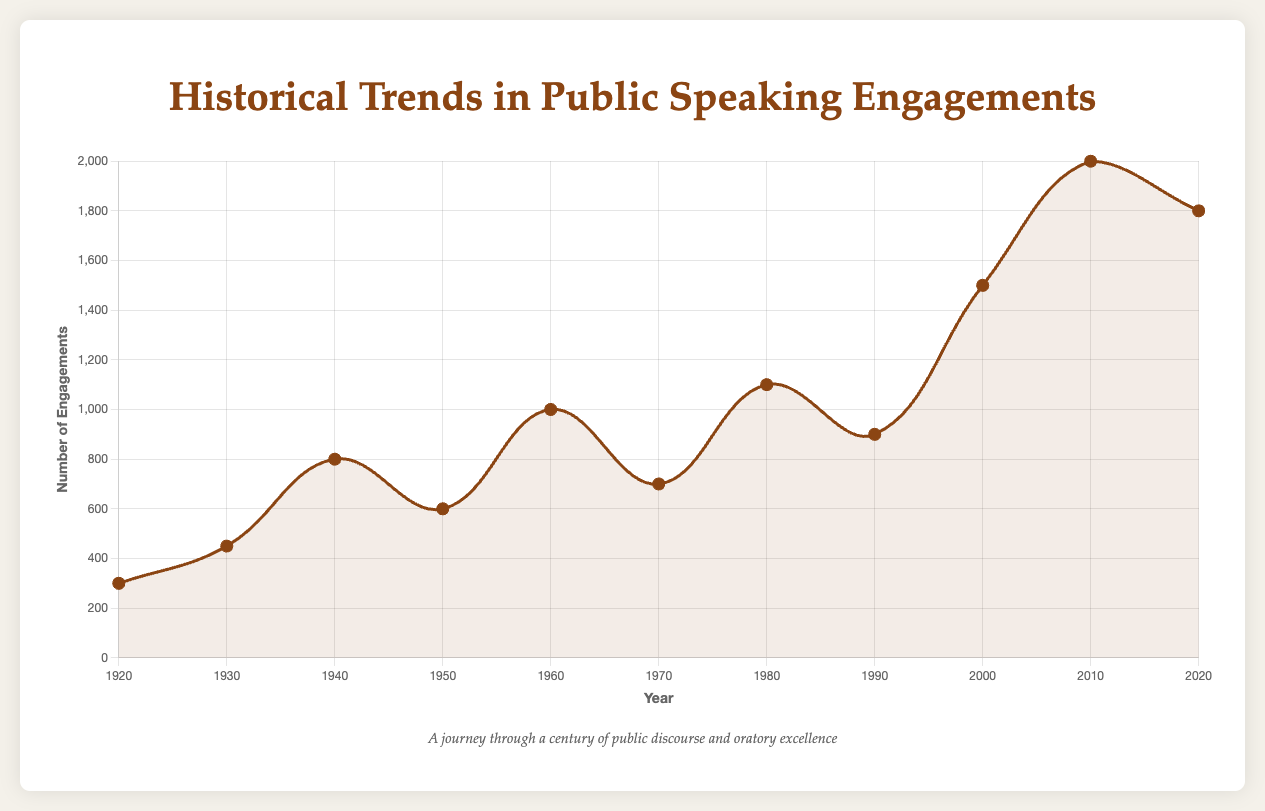What year saw the highest number of public speaking engagements? The graph peaks at 2010, which indicates the highest number of public speaking engagements.
Answer: 2010 Which decade showed a significant rise in the number of public speaking engagements? Comparing the slopes, the decade from 2000 to 2010 shows the sharpest increase, from 1500 to 2000 engagements.
Answer: 2000-2010 Between which years did the number of public speaking engagements decline most prominently? Observing the downward slopes, the most notable decline is from 2010 to 2020, dropping from 2000 to 1800 engagements.
Answer: 2010-2020 What was the approximate difference in the number of public speaking engagements between 1920 and 2020? The number of engagements in 1920 was 300, and in 2020 it was 1800. The difference is calculated as 1800 - 300.
Answer: 1500 Which period had a higher number of public speaking engagements, the 1940s or the 1950s? By examining the points for 1940 and 1950, 1940 had 800 engagements, and 1950 had 600. The 1940s had more engagements.
Answer: 1940s What is the average number of public speaking engagements over the century? Summing the number of engagements from all data points (300 + 450 + 800 + 600 + 1000 + 700 + 1100 + 900 + 1500 + 2000 + 1800) gives 10150, divided by 11 data points gives the average.
Answer: 922.73 How many more engagements were there in 2010 compared to 1930? Subtract the number of engagements in 1930 (450) from those in 2010 (2000).
Answer: 1550 During which significant event did public speaking engagements see a peak around World War II? The data point for WWII (1940) shows 800, demonstrating an increase around that time period.
Answer: WWII (1940) What's the combined number of public speaking engagements during the decades of the Cold War developments and Digital Revolution? Adding the engagements of the 1970s (700) and 2000s (1500) results in a combined total.
Answer: 2200 Which era had a greater decrease in engagements, from the 1960s to 1970s, or 2010 to 2020? The number dropped from 1000 to 700 (300 decrease) in the 1960s-70s, but from 2000 to 1800 (200 decrease) in 2010-2020.
Answer: 1960s to 1970s 